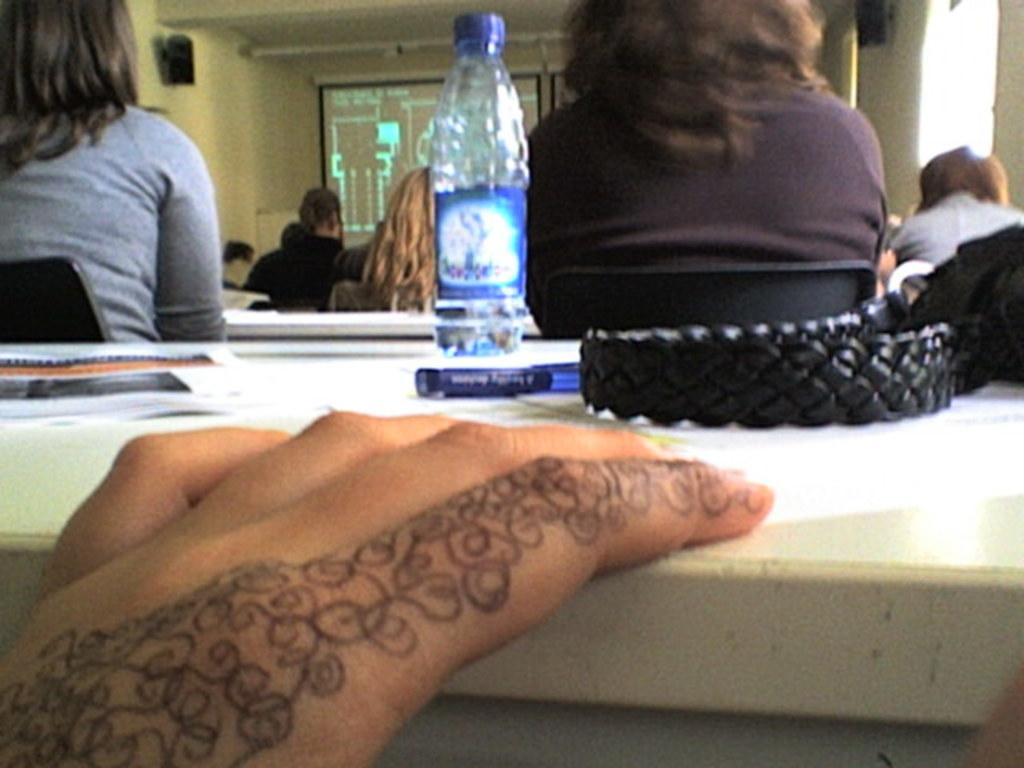What part of the human body can be seen in the image? There is a human hand in the image. What objects are on the table in the image? There is a bottle and a pan on the table in the image. What can be seen in the background of the image? There are people sitting, a projector, and a wall in the background. Can you see a goldfish swimming in the pan in the image? No, there is no goldfish present in the image. Is there a boat visible in the background of the image? No, there is no boat present in the image. 